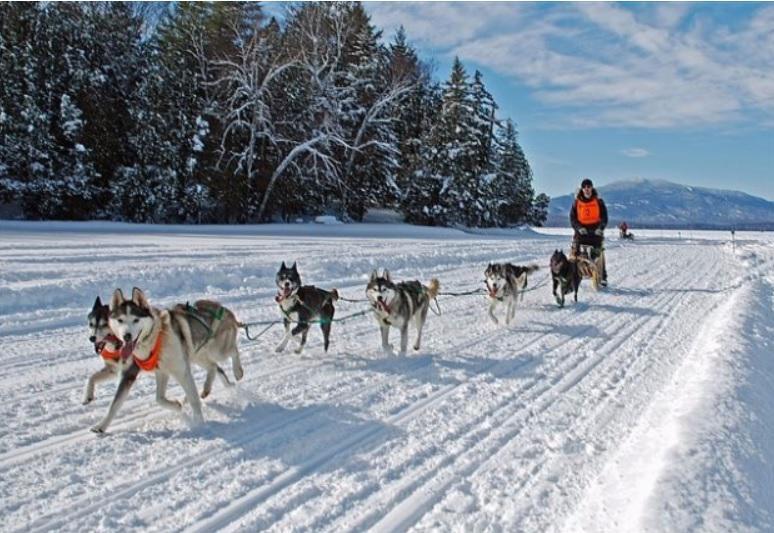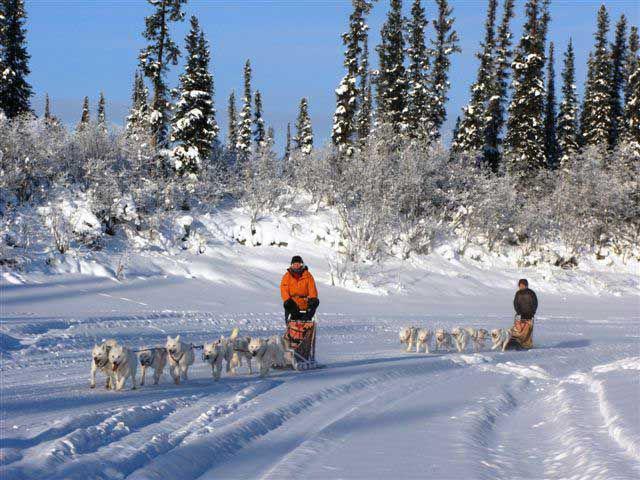The first image is the image on the left, the second image is the image on the right. Examine the images to the left and right. Is the description "In at least one image there are at least five snow dogs leading a man in a red coat on the sled." accurate? Answer yes or no. No. The first image is the image on the left, the second image is the image on the right. Examine the images to the left and right. Is the description "All dog sled teams are heading diagonally to the left with evergreen trees in the background." accurate? Answer yes or no. Yes. 